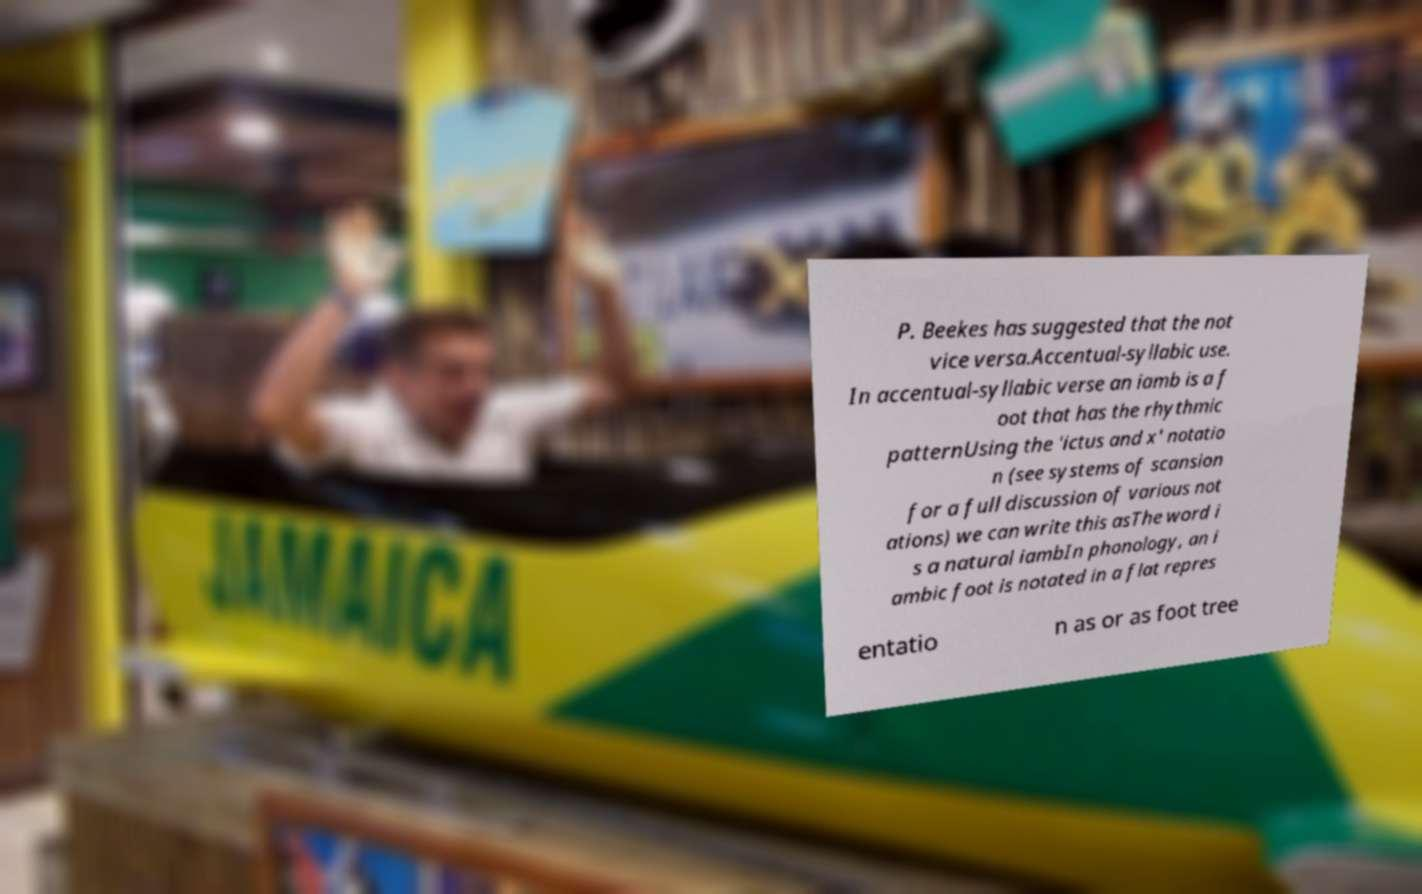Please read and relay the text visible in this image. What does it say? P. Beekes has suggested that the not vice versa.Accentual-syllabic use. In accentual-syllabic verse an iamb is a f oot that has the rhythmic patternUsing the 'ictus and x' notatio n (see systems of scansion for a full discussion of various not ations) we can write this asThe word i s a natural iambIn phonology, an i ambic foot is notated in a flat repres entatio n as or as foot tree 